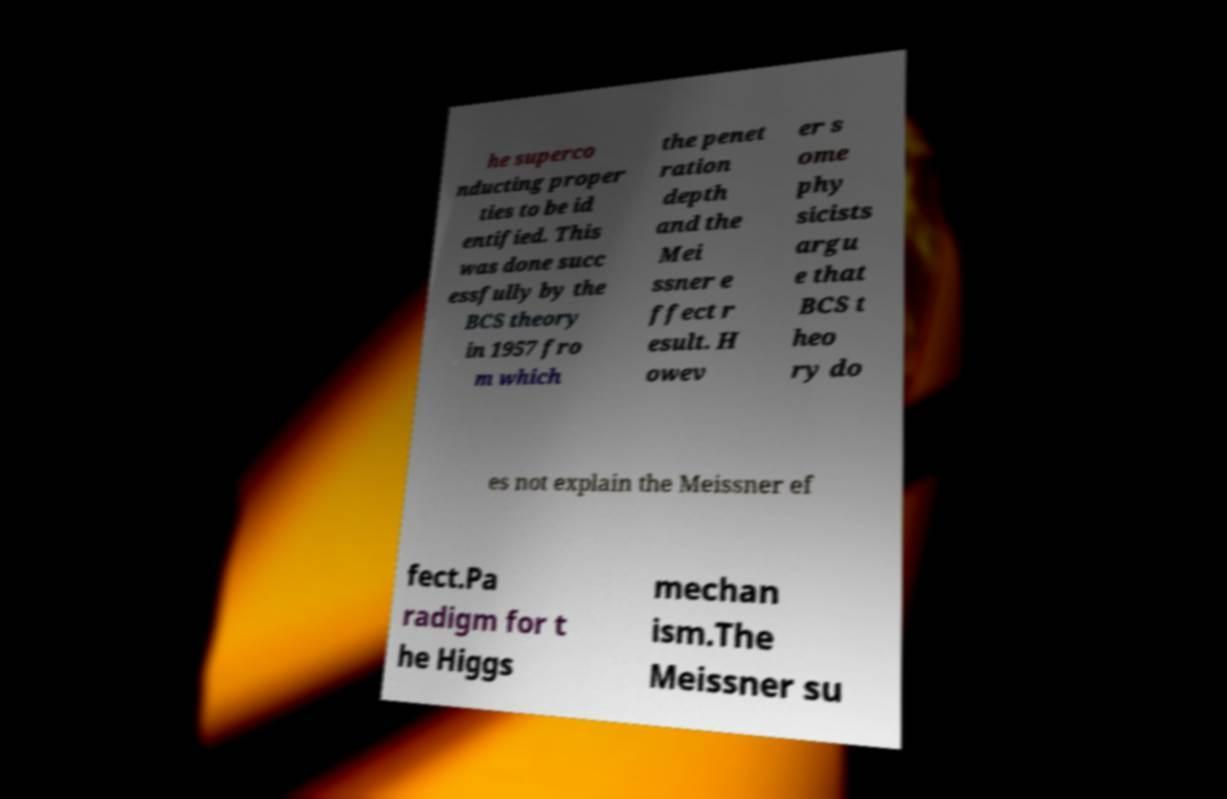Could you assist in decoding the text presented in this image and type it out clearly? he superco nducting proper ties to be id entified. This was done succ essfully by the BCS theory in 1957 fro m which the penet ration depth and the Mei ssner e ffect r esult. H owev er s ome phy sicists argu e that BCS t heo ry do es not explain the Meissner ef fect.Pa radigm for t he Higgs mechan ism.The Meissner su 